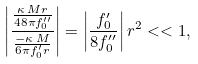<formula> <loc_0><loc_0><loc_500><loc_500>\left | \frac { \frac { \kappa \, M r } { 4 8 \pi f _ { 0 } ^ { \prime \prime } } } { \frac { - \kappa \, M } { 6 \pi f _ { 0 } ^ { \prime } r } } \right | = \left | \frac { f _ { 0 } ^ { \prime } } { 8 f _ { 0 } ^ { \prime \prime } } \right | r ^ { 2 } < < 1 ,</formula> 